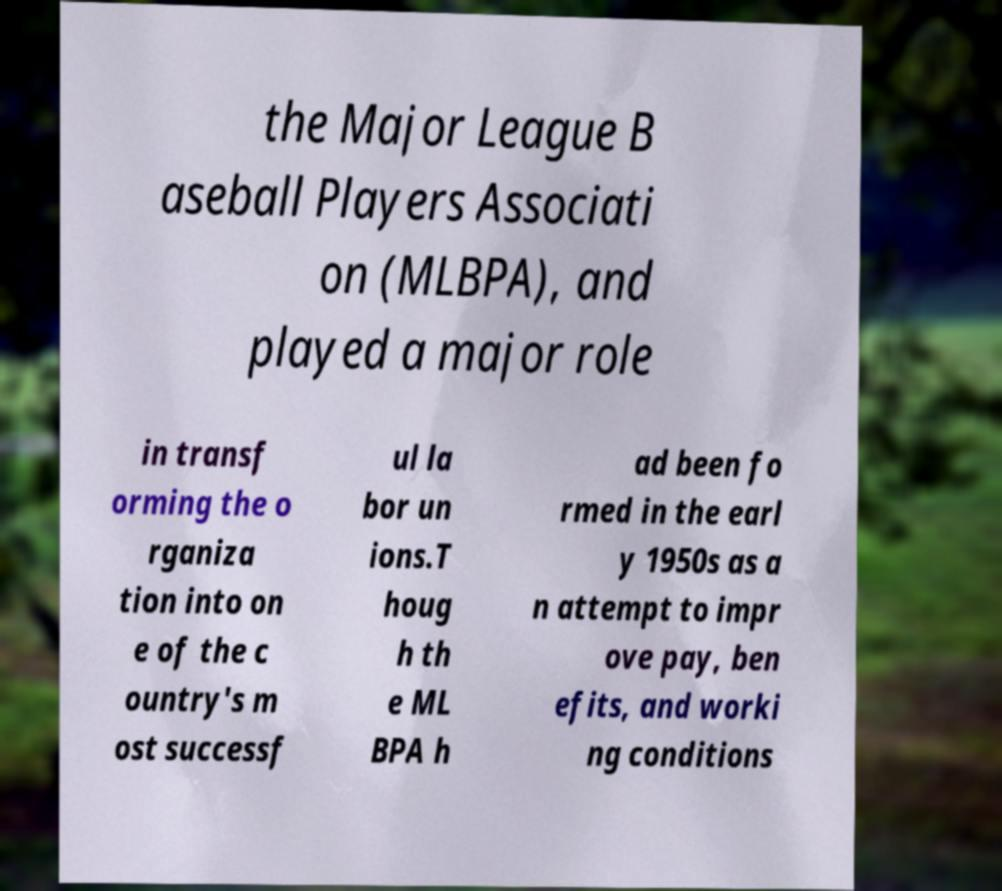There's text embedded in this image that I need extracted. Can you transcribe it verbatim? the Major League B aseball Players Associati on (MLBPA), and played a major role in transf orming the o rganiza tion into on e of the c ountry's m ost successf ul la bor un ions.T houg h th e ML BPA h ad been fo rmed in the earl y 1950s as a n attempt to impr ove pay, ben efits, and worki ng conditions 